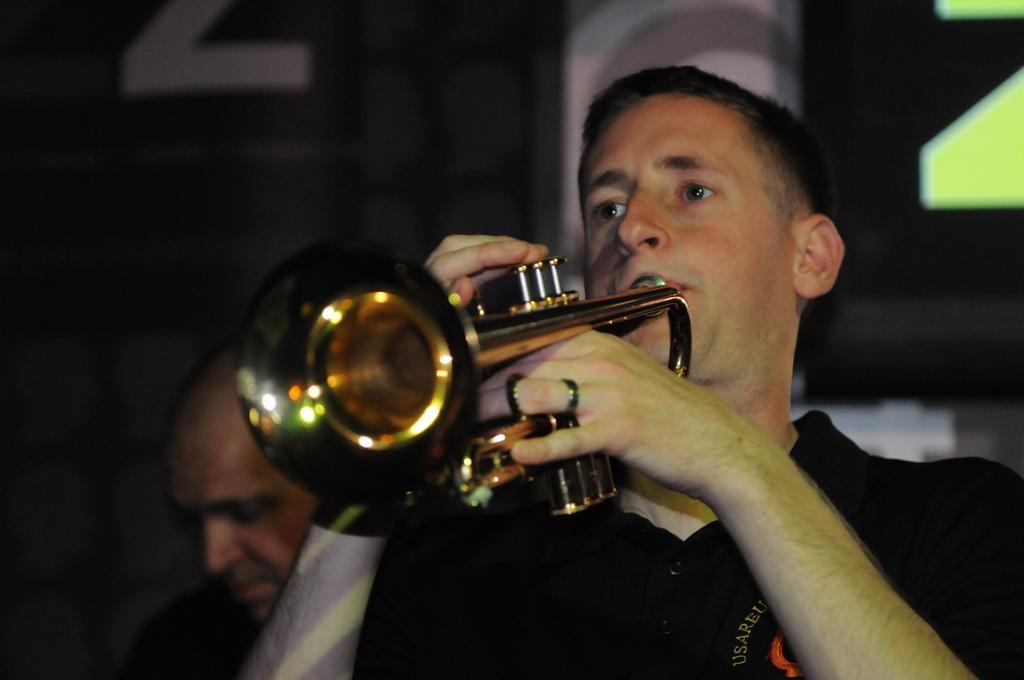How would you summarize this image in a sentence or two? As we can see in the image in the front there are two people. The man over here is wearing black color t shirt and holding musical instrument. In the background there is a building. 